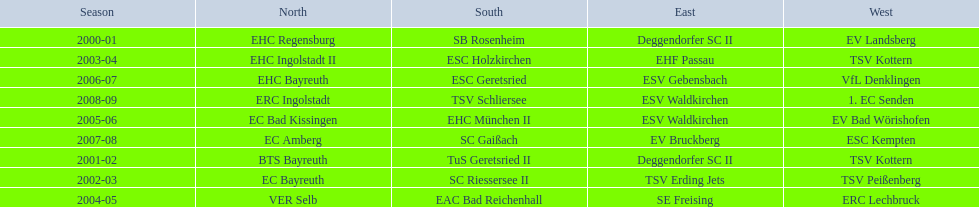Parse the table in full. {'header': ['Season', 'North', 'South', 'East', 'West'], 'rows': [['2000-01', 'EHC Regensburg', 'SB Rosenheim', 'Deggendorfer SC II', 'EV Landsberg'], ['2003-04', 'EHC Ingolstadt II', 'ESC Holzkirchen', 'EHF Passau', 'TSV Kottern'], ['2006-07', 'EHC Bayreuth', 'ESC Geretsried', 'ESV Gebensbach', 'VfL Denklingen'], ['2008-09', 'ERC Ingolstadt', 'TSV Schliersee', 'ESV Waldkirchen', '1. EC Senden'], ['2005-06', 'EC Bad Kissingen', 'EHC München II', 'ESV Waldkirchen', 'EV Bad Wörishofen'], ['2007-08', 'EC Amberg', 'SC Gaißach', 'EV Bruckberg', 'ESC Kempten'], ['2001-02', 'BTS Bayreuth', 'TuS Geretsried II', 'Deggendorfer SC II', 'TSV Kottern'], ['2002-03', 'EC Bayreuth', 'SC Riessersee II', 'TSV Erding Jets', 'TSV Peißenberg'], ['2004-05', 'VER Selb', 'EAC Bad Reichenhall', 'SE Freising', 'ERC Lechbruck']]} Which name appears more often, kottern or bayreuth? Bayreuth. 